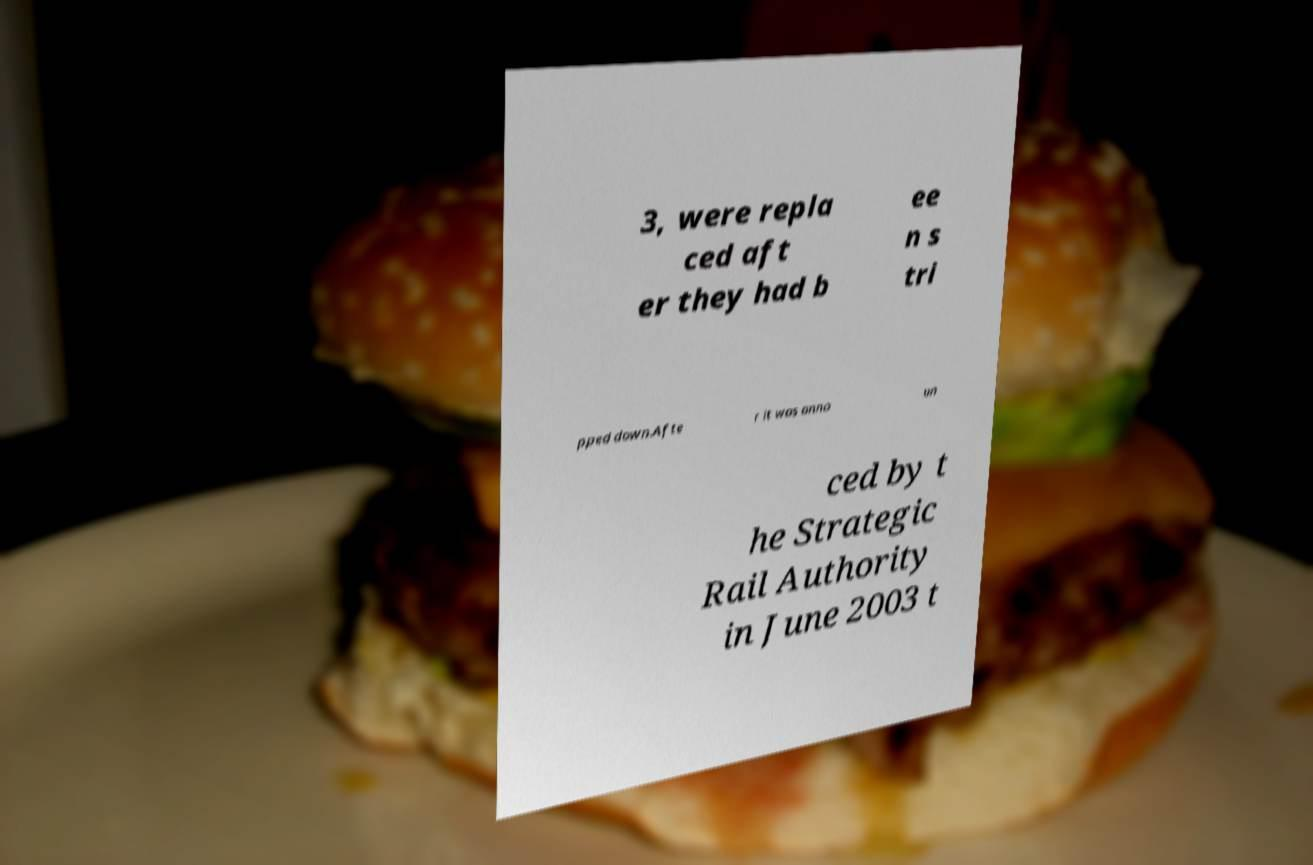Please identify and transcribe the text found in this image. 3, were repla ced aft er they had b ee n s tri pped down.Afte r it was anno un ced by t he Strategic Rail Authority in June 2003 t 